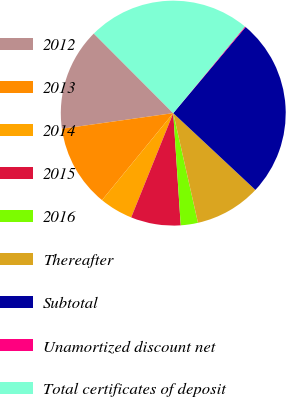Convert chart to OTSL. <chart><loc_0><loc_0><loc_500><loc_500><pie_chart><fcel>2012<fcel>2013<fcel>2014<fcel>2015<fcel>2016<fcel>Thereafter<fcel>Subtotal<fcel>Unamortized discount net<fcel>Total certificates of deposit<nl><fcel>14.74%<fcel>11.86%<fcel>4.82%<fcel>7.16%<fcel>2.47%<fcel>9.51%<fcel>25.84%<fcel>0.12%<fcel>23.49%<nl></chart> 